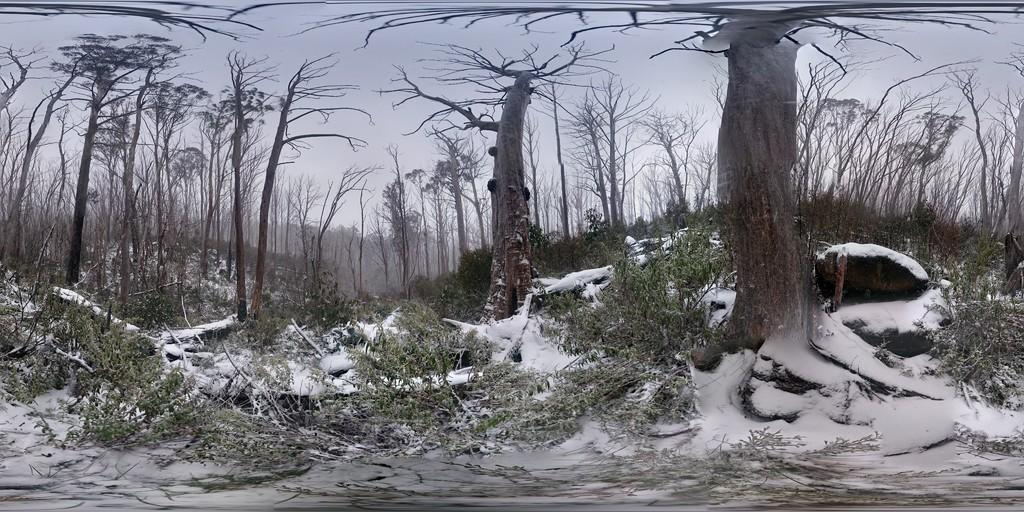What can be seen in the sky in the image? The sky is visible in the image. What type of vegetation is present in the image? There are trees in the image. What weather condition is depicted in the image? There is snow in the image. Can you see a volleyball being played in the snow in the image? There is no volleyball or any indication of a game being played in the image. What type of pump is visible in the image? There is no pump present in the image. 